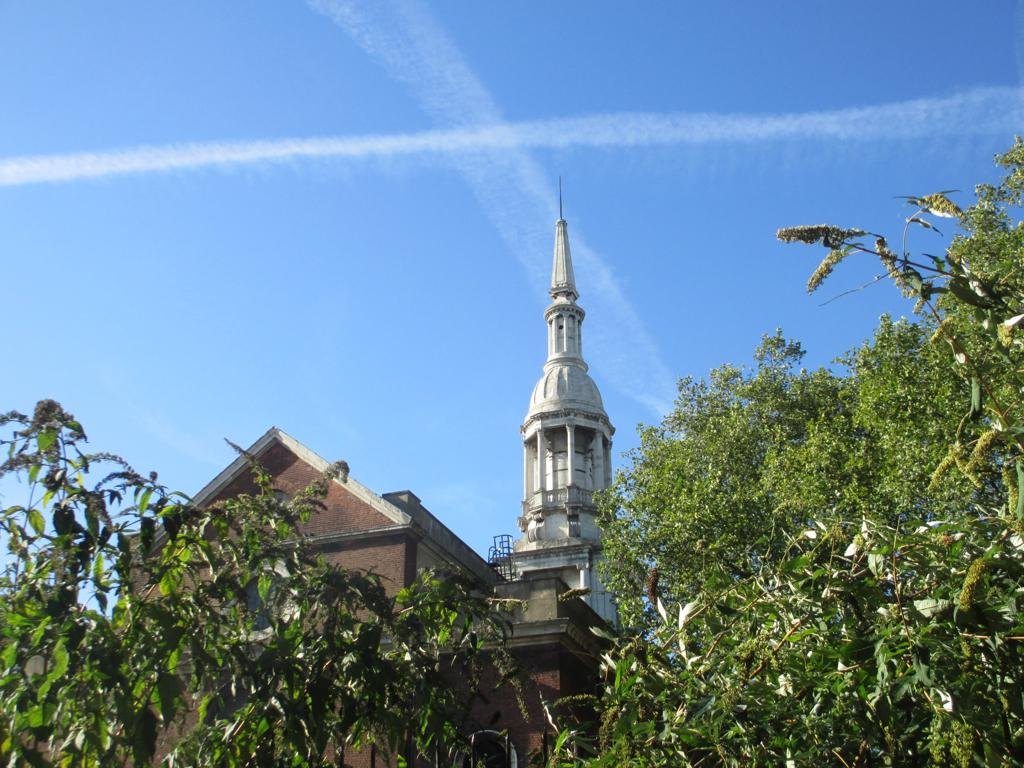What type of vegetation is present in the image? There are trees in the image. What is the color of the trees? The trees are green in color. What can be seen in the background of the image? There are buildings in the background of the image. What is the color of the buildings? The buildings are brown and white in color. What is visible above the trees and buildings in the image? The sky is visible in the image. What is the color of the sky? The sky is blue and white in color. What type of flesh can be seen hanging from the trees in the image? There is no flesh present in the image; the trees are green and have leaves. What flavor of chain can be seen connecting the buildings in the image? There is no chain present in the image, and the buildings are connected by their proximity to each other. 